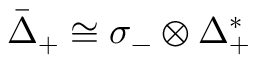Convert formula to latex. <formula><loc_0><loc_0><loc_500><loc_500>{ \bar { \Delta } } _ { + } \cong \sigma _ { - } \otimes \Delta _ { + } ^ { * }</formula> 